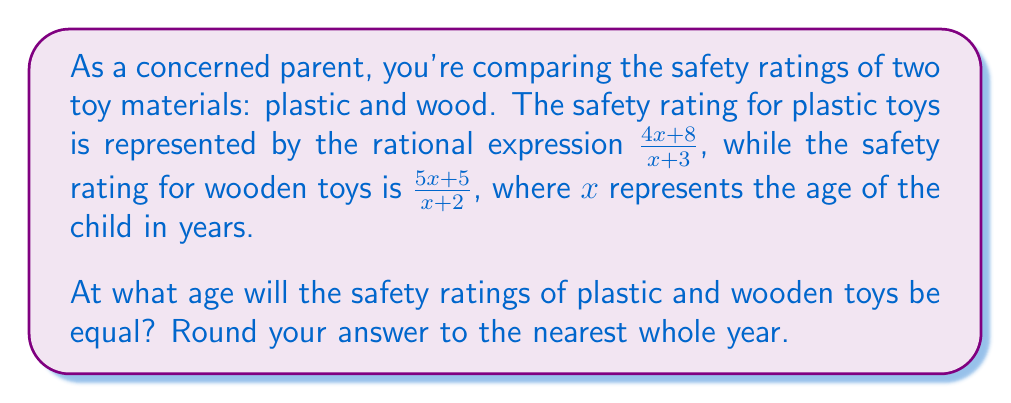What is the answer to this math problem? To find the age when the safety ratings are equal, we need to set the two rational expressions equal to each other and solve for $x$:

$$\frac{4x+8}{x+3} = \frac{5x+5}{x+2}$$

Step 1: Cross-multiply to eliminate the denominators:
$$(4x+8)(x+2) = (5x+5)(x+3)$$

Step 2: Expand the expressions:
$$4x^2 + 8x + 8x + 16 = 5x^2 + 15x + 5x + 15$$
$$4x^2 + 16x + 16 = 5x^2 + 20x + 15$$

Step 3: Subtract the right side from both sides:
$$4x^2 + 16x + 16 - (5x^2 + 20x + 15) = 0$$
$$-x^2 - 4x + 1 = 0$$

Step 4: Solve the quadratic equation using the quadratic formula:
$$x = \frac{-b \pm \sqrt{b^2 - 4ac}}{2a}$$
Where $a=-1$, $b=-4$, and $c=1$

$$x = \frac{4 \pm \sqrt{16 - 4(-1)(1)}}{2(-1)}$$
$$x = \frac{4 \pm \sqrt{20}}{-2}$$

Step 5: Simplify and calculate the two solutions:
$$x = -2 \pm \frac{\sqrt{20}}{2} \approx 0.24 \text{ or } -4.24$$

Step 6: Since age cannot be negative, we discard the negative solution. Rounding 0.24 to the nearest whole year gives us 0 years.
Answer: 0 years 